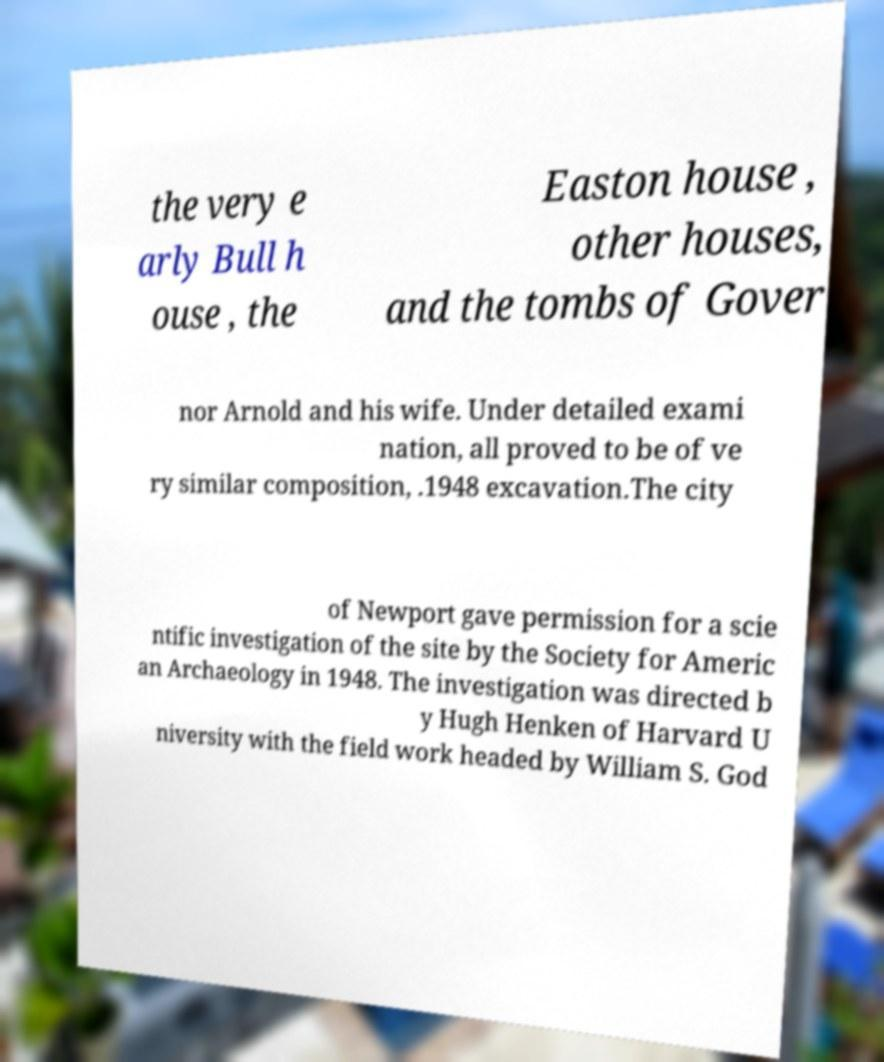Can you accurately transcribe the text from the provided image for me? the very e arly Bull h ouse , the Easton house , other houses, and the tombs of Gover nor Arnold and his wife. Under detailed exami nation, all proved to be of ve ry similar composition, .1948 excavation.The city of Newport gave permission for a scie ntific investigation of the site by the Society for Americ an Archaeology in 1948. The investigation was directed b y Hugh Henken of Harvard U niversity with the field work headed by William S. God 